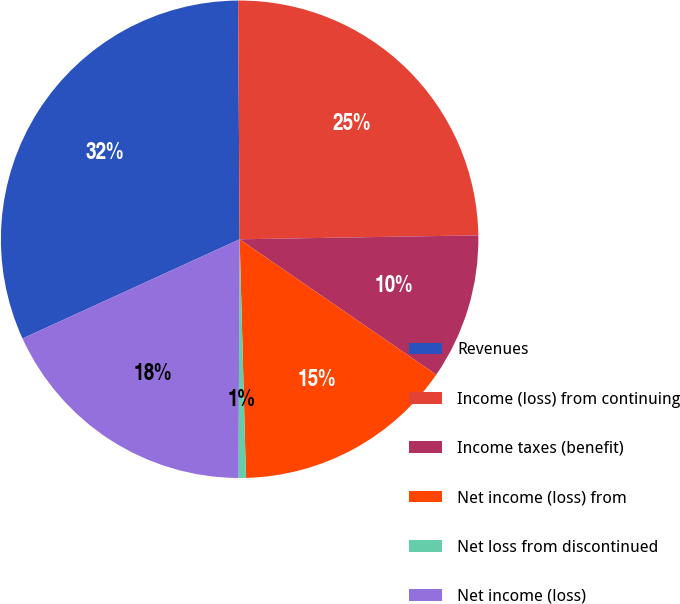Convert chart to OTSL. <chart><loc_0><loc_0><loc_500><loc_500><pie_chart><fcel>Revenues<fcel>Income (loss) from continuing<fcel>Income taxes (benefit)<fcel>Net income (loss) from<fcel>Net loss from discontinued<fcel>Net income (loss)<nl><fcel>31.72%<fcel>24.84%<fcel>9.86%<fcel>14.98%<fcel>0.5%<fcel>18.1%<nl></chart> 